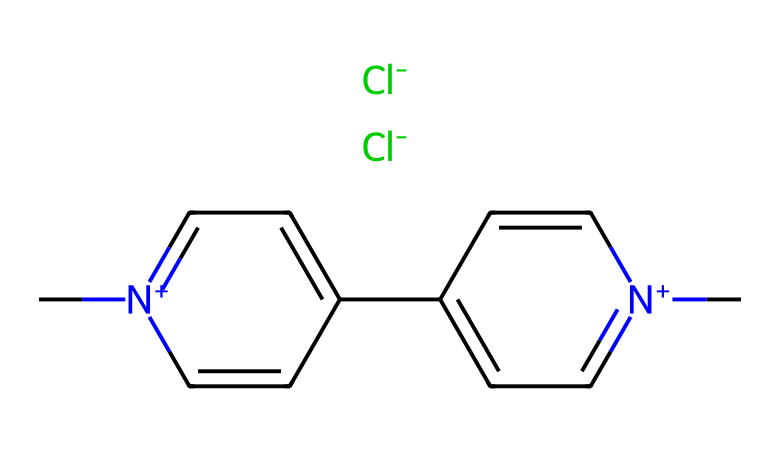What is the molecular formula of paraquat? By analyzing the provided SMILES, we can identify the atoms present: there are carbons (C), nitrogens (N), and chlorines (Cl). The chemical formula can be derived as C12H14Cl2N2.
Answer: C12H14Cl2N2 How many chlorine (Cl) atoms are in paraquat? Looking closely at the SMILES representation, two “[Cl-]” components indicate the presence of two chlorine atoms in the structure.
Answer: 2 What type of herbicide is paraquat classified as? Paraquat is classified as a non-selective herbicide, as it kills a wide range of weeds and plants by disrupting photosynthesis.
Answer: non-selective What functional groups are present in paraquat? The presence of the nitrogen atom in a cationic form and the halides with chlorine (Cl) indicates that paraquat contains quaternary ammonium and halogen functional groups.
Answer: quaternary ammonium and halogen How does the structure of paraquat contribute to its toxicity? The structure, particularly the presence of the two positively charged nitrogen atoms (indicating a quaternary amine), allows paraquat to readily enter plant cells and disrupt photosynthesis which is also linked to its high toxicity in mammals.
Answer: high toxicity in mammals What is the total number of nitrogen (N) atoms in the molecular structure of paraquat? The SMILES shows two instances of the nitrogen symbol (N), confirming there are two nitrogen atoms in the paraquat molecule.
Answer: 2 Is paraquat considered safe for agricultural use? Due to its high toxicity and potential health risks, paraquat is heavily regulated and considered unsafe for general agricultural use in many countries.
Answer: unsafe 